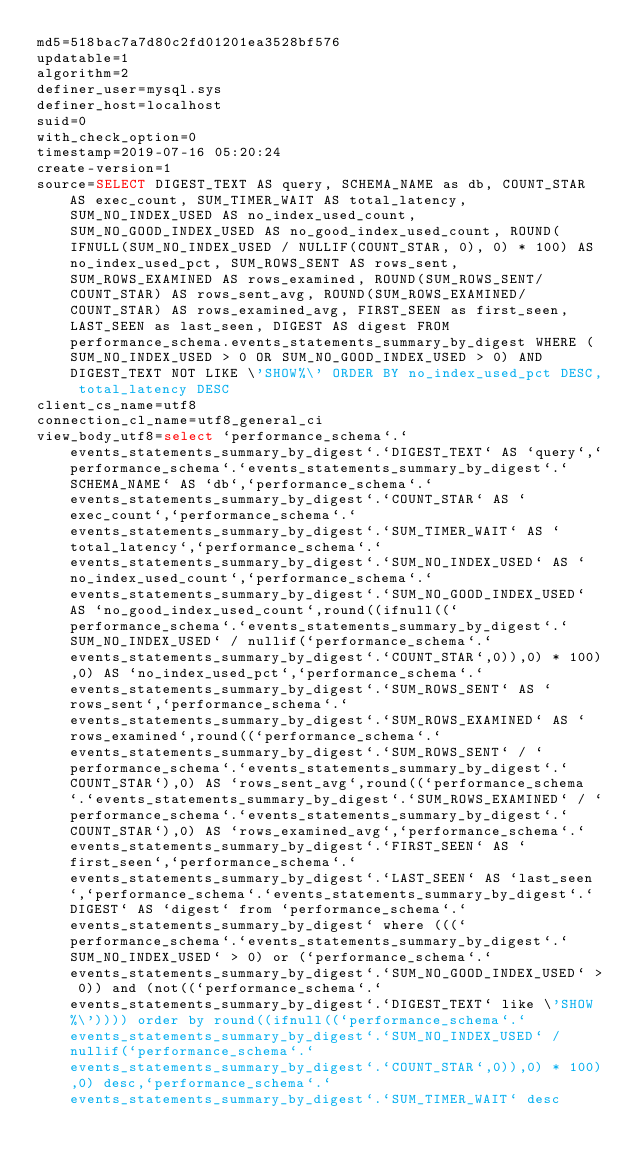Convert code to text. <code><loc_0><loc_0><loc_500><loc_500><_VisualBasic_>md5=518bac7a7d80c2fd01201ea3528bf576
updatable=1
algorithm=2
definer_user=mysql.sys
definer_host=localhost
suid=0
with_check_option=0
timestamp=2019-07-16 05:20:24
create-version=1
source=SELECT DIGEST_TEXT AS query, SCHEMA_NAME as db, COUNT_STAR AS exec_count, SUM_TIMER_WAIT AS total_latency, SUM_NO_INDEX_USED AS no_index_used_count, SUM_NO_GOOD_INDEX_USED AS no_good_index_used_count, ROUND(IFNULL(SUM_NO_INDEX_USED / NULLIF(COUNT_STAR, 0), 0) * 100) AS no_index_used_pct, SUM_ROWS_SENT AS rows_sent, SUM_ROWS_EXAMINED AS rows_examined, ROUND(SUM_ROWS_SENT/COUNT_STAR) AS rows_sent_avg, ROUND(SUM_ROWS_EXAMINED/COUNT_STAR) AS rows_examined_avg, FIRST_SEEN as first_seen, LAST_SEEN as last_seen, DIGEST AS digest FROM performance_schema.events_statements_summary_by_digest WHERE (SUM_NO_INDEX_USED > 0 OR SUM_NO_GOOD_INDEX_USED > 0) AND DIGEST_TEXT NOT LIKE \'SHOW%\' ORDER BY no_index_used_pct DESC, total_latency DESC
client_cs_name=utf8
connection_cl_name=utf8_general_ci
view_body_utf8=select `performance_schema`.`events_statements_summary_by_digest`.`DIGEST_TEXT` AS `query`,`performance_schema`.`events_statements_summary_by_digest`.`SCHEMA_NAME` AS `db`,`performance_schema`.`events_statements_summary_by_digest`.`COUNT_STAR` AS `exec_count`,`performance_schema`.`events_statements_summary_by_digest`.`SUM_TIMER_WAIT` AS `total_latency`,`performance_schema`.`events_statements_summary_by_digest`.`SUM_NO_INDEX_USED` AS `no_index_used_count`,`performance_schema`.`events_statements_summary_by_digest`.`SUM_NO_GOOD_INDEX_USED` AS `no_good_index_used_count`,round((ifnull((`performance_schema`.`events_statements_summary_by_digest`.`SUM_NO_INDEX_USED` / nullif(`performance_schema`.`events_statements_summary_by_digest`.`COUNT_STAR`,0)),0) * 100),0) AS `no_index_used_pct`,`performance_schema`.`events_statements_summary_by_digest`.`SUM_ROWS_SENT` AS `rows_sent`,`performance_schema`.`events_statements_summary_by_digest`.`SUM_ROWS_EXAMINED` AS `rows_examined`,round((`performance_schema`.`events_statements_summary_by_digest`.`SUM_ROWS_SENT` / `performance_schema`.`events_statements_summary_by_digest`.`COUNT_STAR`),0) AS `rows_sent_avg`,round((`performance_schema`.`events_statements_summary_by_digest`.`SUM_ROWS_EXAMINED` / `performance_schema`.`events_statements_summary_by_digest`.`COUNT_STAR`),0) AS `rows_examined_avg`,`performance_schema`.`events_statements_summary_by_digest`.`FIRST_SEEN` AS `first_seen`,`performance_schema`.`events_statements_summary_by_digest`.`LAST_SEEN` AS `last_seen`,`performance_schema`.`events_statements_summary_by_digest`.`DIGEST` AS `digest` from `performance_schema`.`events_statements_summary_by_digest` where (((`performance_schema`.`events_statements_summary_by_digest`.`SUM_NO_INDEX_USED` > 0) or (`performance_schema`.`events_statements_summary_by_digest`.`SUM_NO_GOOD_INDEX_USED` > 0)) and (not((`performance_schema`.`events_statements_summary_by_digest`.`DIGEST_TEXT` like \'SHOW%\')))) order by round((ifnull((`performance_schema`.`events_statements_summary_by_digest`.`SUM_NO_INDEX_USED` / nullif(`performance_schema`.`events_statements_summary_by_digest`.`COUNT_STAR`,0)),0) * 100),0) desc,`performance_schema`.`events_statements_summary_by_digest`.`SUM_TIMER_WAIT` desc
</code> 